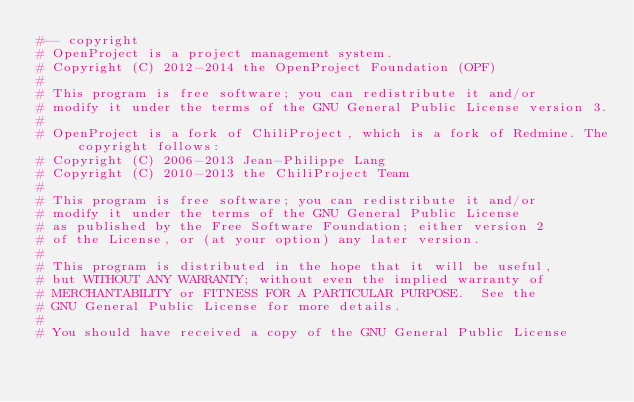Convert code to text. <code><loc_0><loc_0><loc_500><loc_500><_Ruby_>#-- copyright
# OpenProject is a project management system.
# Copyright (C) 2012-2014 the OpenProject Foundation (OPF)
#
# This program is free software; you can redistribute it and/or
# modify it under the terms of the GNU General Public License version 3.
#
# OpenProject is a fork of ChiliProject, which is a fork of Redmine. The copyright follows:
# Copyright (C) 2006-2013 Jean-Philippe Lang
# Copyright (C) 2010-2013 the ChiliProject Team
#
# This program is free software; you can redistribute it and/or
# modify it under the terms of the GNU General Public License
# as published by the Free Software Foundation; either version 2
# of the License, or (at your option) any later version.
#
# This program is distributed in the hope that it will be useful,
# but WITHOUT ANY WARRANTY; without even the implied warranty of
# MERCHANTABILITY or FITNESS FOR A PARTICULAR PURPOSE.  See the
# GNU General Public License for more details.
#
# You should have received a copy of the GNU General Public License</code> 